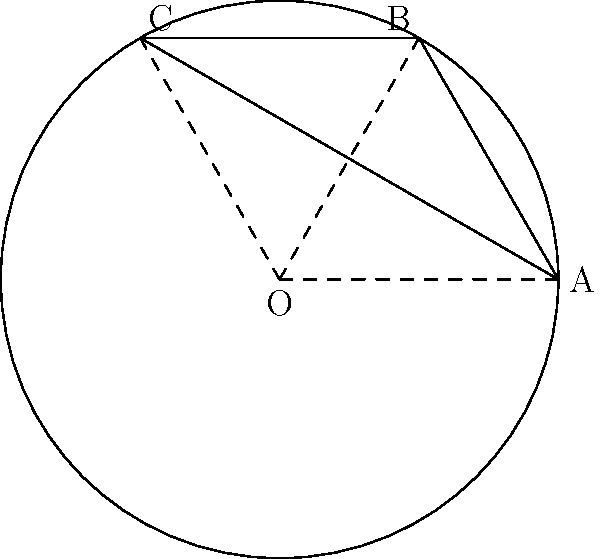Consider a soccer ball's surface as a sphere, which is an example of a Non-Euclidean geometry. In the diagram, triangle ABC is drawn on the surface of the sphere with center O. If the sum of the interior angles of triangle ABC is 210°, what is the ratio of the area of triangle ABC to the total surface area of the sphere? To solve this problem, we'll use the concepts of spherical geometry and the Gauss-Bonnet theorem. Let's break it down step-by-step:

1) In spherical geometry, the sum of angles in a triangle is always greater than 180°. The excess over 180° is directly related to the area of the triangle.

2) Let's define the angle excess: $E = (\text{sum of angles}) - 180°$
   In this case, $E = 210° - 180° = 30°$

3) The Gauss-Bonnet theorem states that for a triangle on a sphere of radius $r$:
   $A = Er^2$
   Where $A$ is the area of the triangle and $E$ is the angle excess in radians.

4) We need to convert 30° to radians:
   $30° * \frac{\pi}{180°} = \frac{\pi}{6}$ radians

5) Now we can calculate the area of the triangle:
   $A = \frac{\pi}{6}r^2$

6) The surface area of a sphere is $4\pi r^2$

7) The ratio of the triangle's area to the sphere's surface area is:

   $\frac{A}{\text{Surface Area}} = \frac{\frac{\pi}{6}r^2}{4\pi r^2} = \frac{1}{24}$

Therefore, the area of triangle ABC is $\frac{1}{24}$ of the total surface area of the sphere.
Answer: $\frac{1}{24}$ 